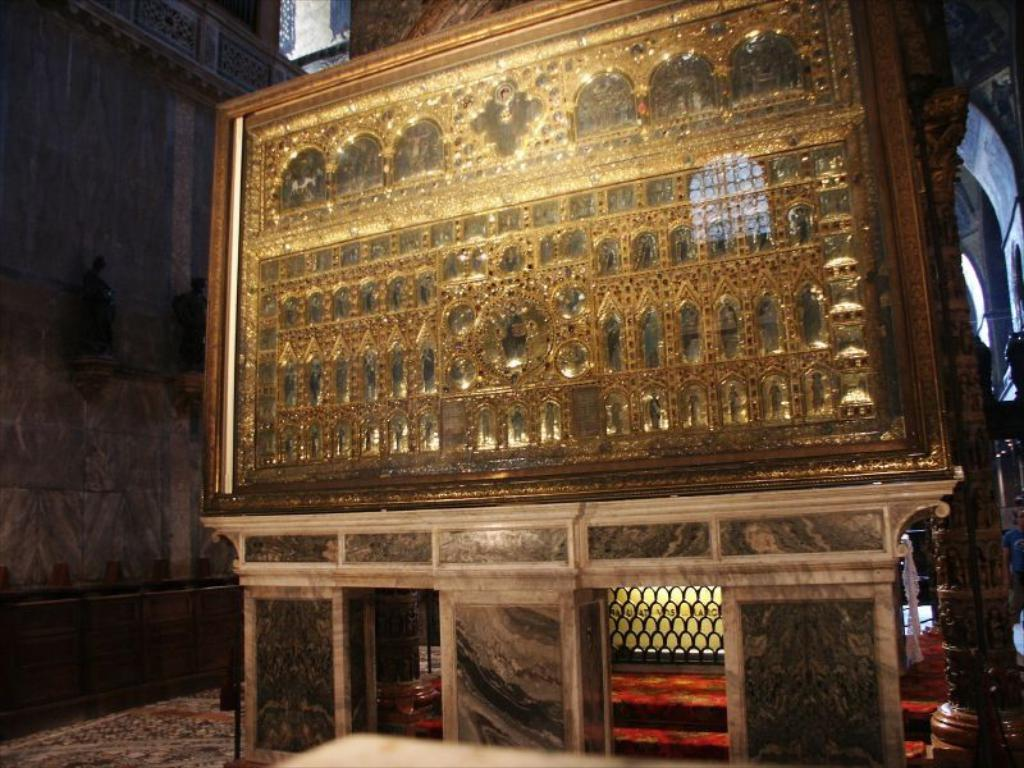What object is present in the image that typically holds a photograph? There is a photo frame in the image. How is the photo frame positioned in the image? The photo frame is placed on a stand. What architectural feature can be seen in the image? There is a pillar visible in the image. What type of structure is suggested by the presence of walls in the image? The presence of walls suggests that the image is taken in a room or an enclosed space. What time of day is being discussed in the image? There is no discussion or mention of time in the image; it only shows a photo frame, a stand, a pillar, and walls. 